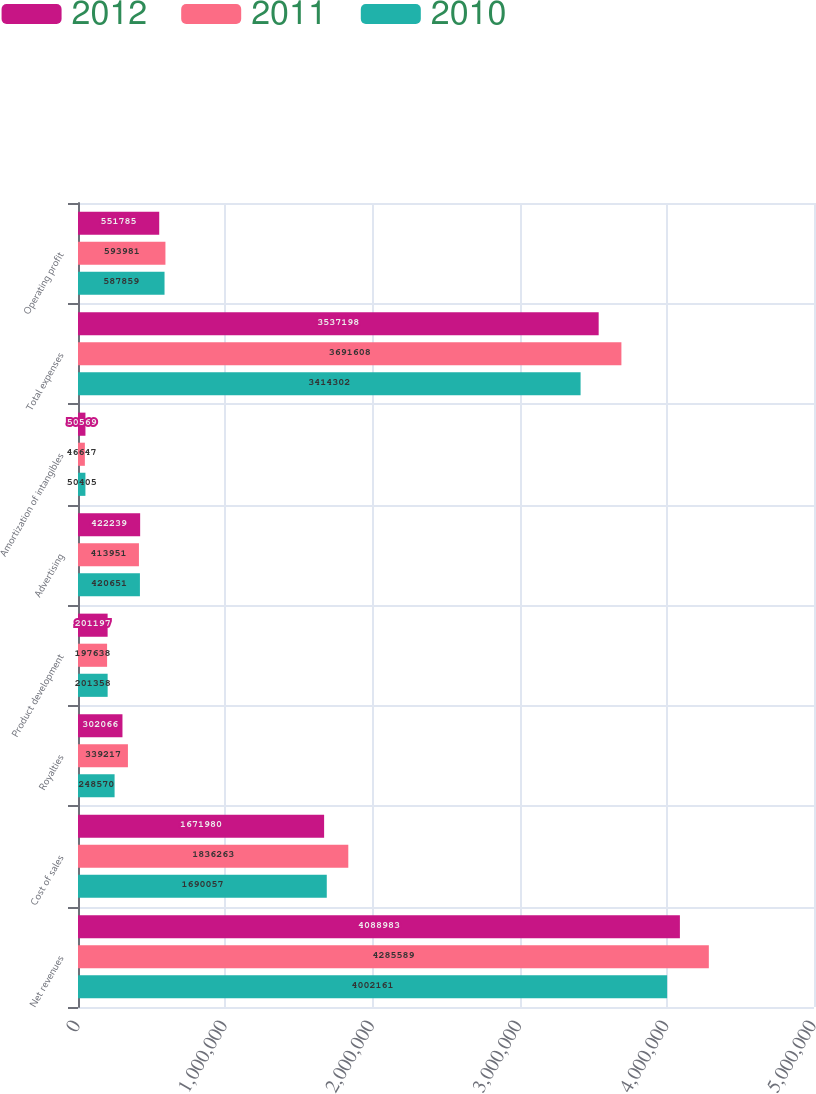<chart> <loc_0><loc_0><loc_500><loc_500><stacked_bar_chart><ecel><fcel>Net revenues<fcel>Cost of sales<fcel>Royalties<fcel>Product development<fcel>Advertising<fcel>Amortization of intangibles<fcel>Total expenses<fcel>Operating profit<nl><fcel>2012<fcel>4.08898e+06<fcel>1.67198e+06<fcel>302066<fcel>201197<fcel>422239<fcel>50569<fcel>3.5372e+06<fcel>551785<nl><fcel>2011<fcel>4.28559e+06<fcel>1.83626e+06<fcel>339217<fcel>197638<fcel>413951<fcel>46647<fcel>3.69161e+06<fcel>593981<nl><fcel>2010<fcel>4.00216e+06<fcel>1.69006e+06<fcel>248570<fcel>201358<fcel>420651<fcel>50405<fcel>3.4143e+06<fcel>587859<nl></chart> 